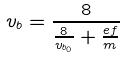Convert formula to latex. <formula><loc_0><loc_0><loc_500><loc_500>v _ { b } = \frac { 8 } { \frac { 8 } { v _ { b _ { 0 } } } + \frac { e f } { m } }</formula> 